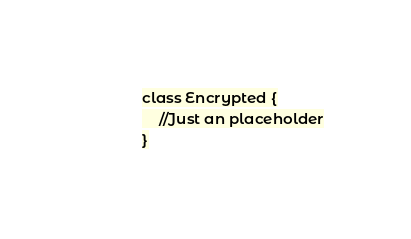Convert code to text. <code><loc_0><loc_0><loc_500><loc_500><_PHP_>class Encrypted {
    //Just an placeholder
}</code> 